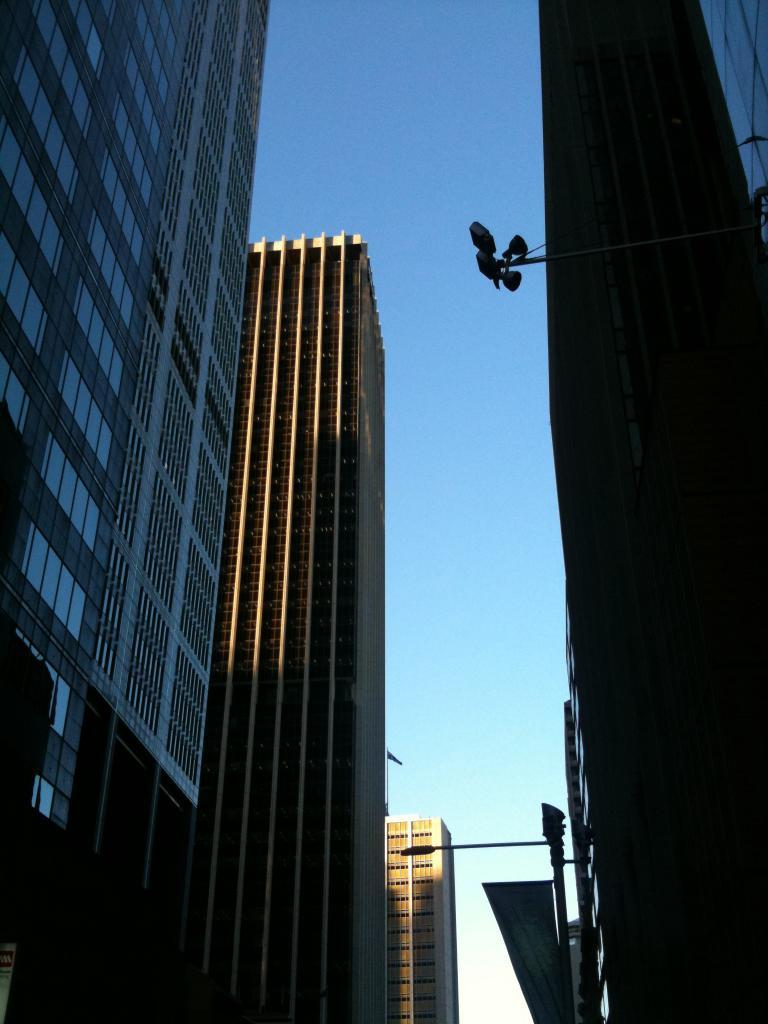What type of structures are present in the image? There are buildings in the image. What can be seen illuminating the scene in the image? There are lights in the image. What object is present that might be used for supporting or holding something? There is a pole in the image. What is visible at the top of the image? The sky is visible at the top of the image. What caption is written on the buildings in the image? There is no caption present on the buildings in the image. Can you tell me how the people in the image are saying good-bye to each other? There are no people visible in the image, so it is not possible to determine how they might be saying good-bye. 